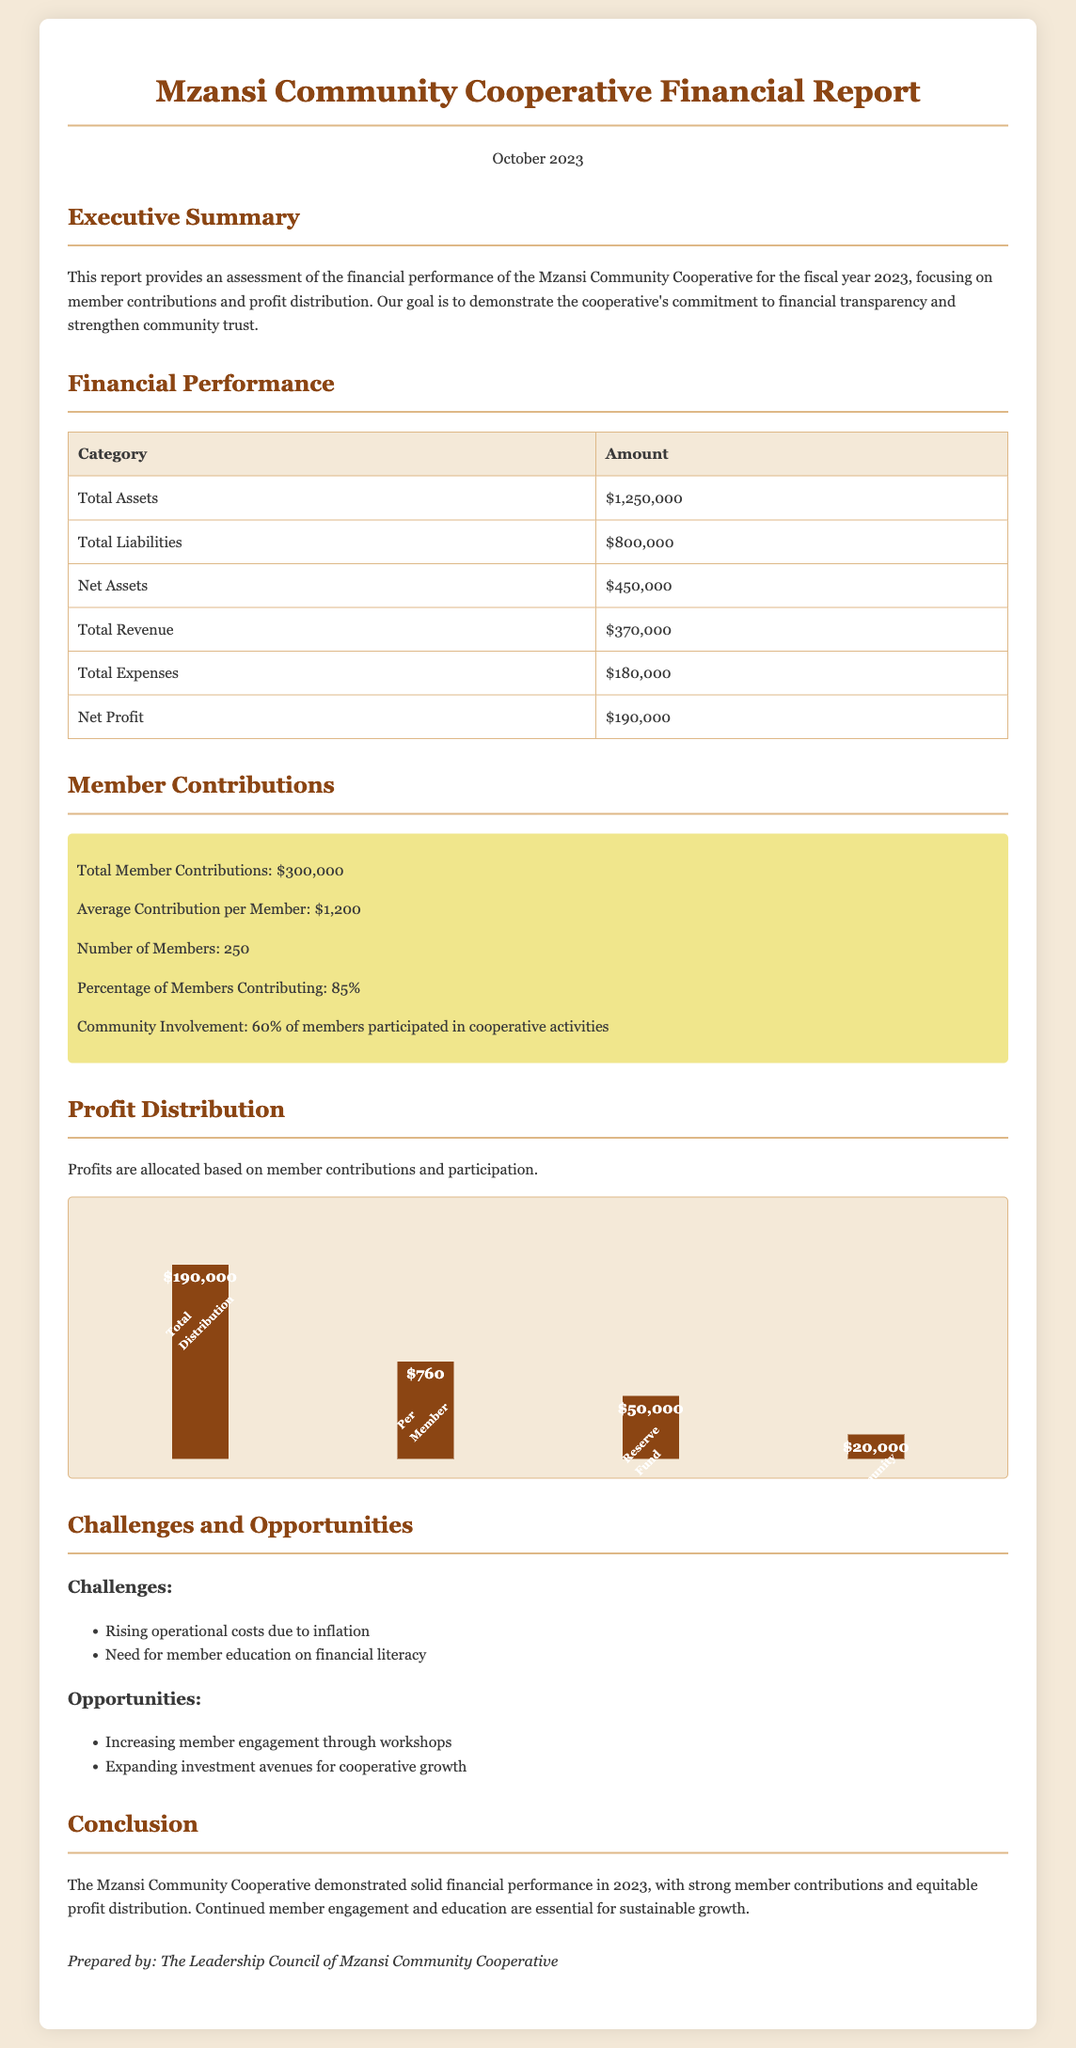what is the total assets? The total assets listed in the financial performance section is the sum of all assets owned by the cooperative.
Answer: $1,250,000 what is the total revenue? The total revenue represents the overall income generated by the cooperative, as stated in the financial performance section.
Answer: $370,000 how many members are there? The number of members contributing to the cooperative is mentioned in the member contributions section of the report.
Answer: 250 what is the average contribution per member? The average contribution per member is calculated by dividing total contributions by the number of members, detailed in the member contributions section.
Answer: $1,200 what percentage of members contributed? This percentage shows the level of participation among members and is provided in the member contributions section.
Answer: 85% what is the net profit? The net profit is the total revenue minus total expenses, as provided in the financial performance section.
Answer: $190,000 how much is allocated for community grants? The amount set aside for community grants is specified in the profit distribution section of the document.
Answer: $20,000 what challenges does the cooperative face? The challenges listed highlight the difficulties the cooperative is currently experiencing, mentioned in the challenges section.
Answer: Rising operational costs due to inflation what is the total distribution amount? The total distribution amount reflects the profits available for distribution among members, as shown in the profit distribution section.
Answer: $190,000 what opportunities are mentioned for the cooperative? The report describes potential avenues for growth and engagement in the opportunities section.
Answer: Increasing member engagement through workshops 